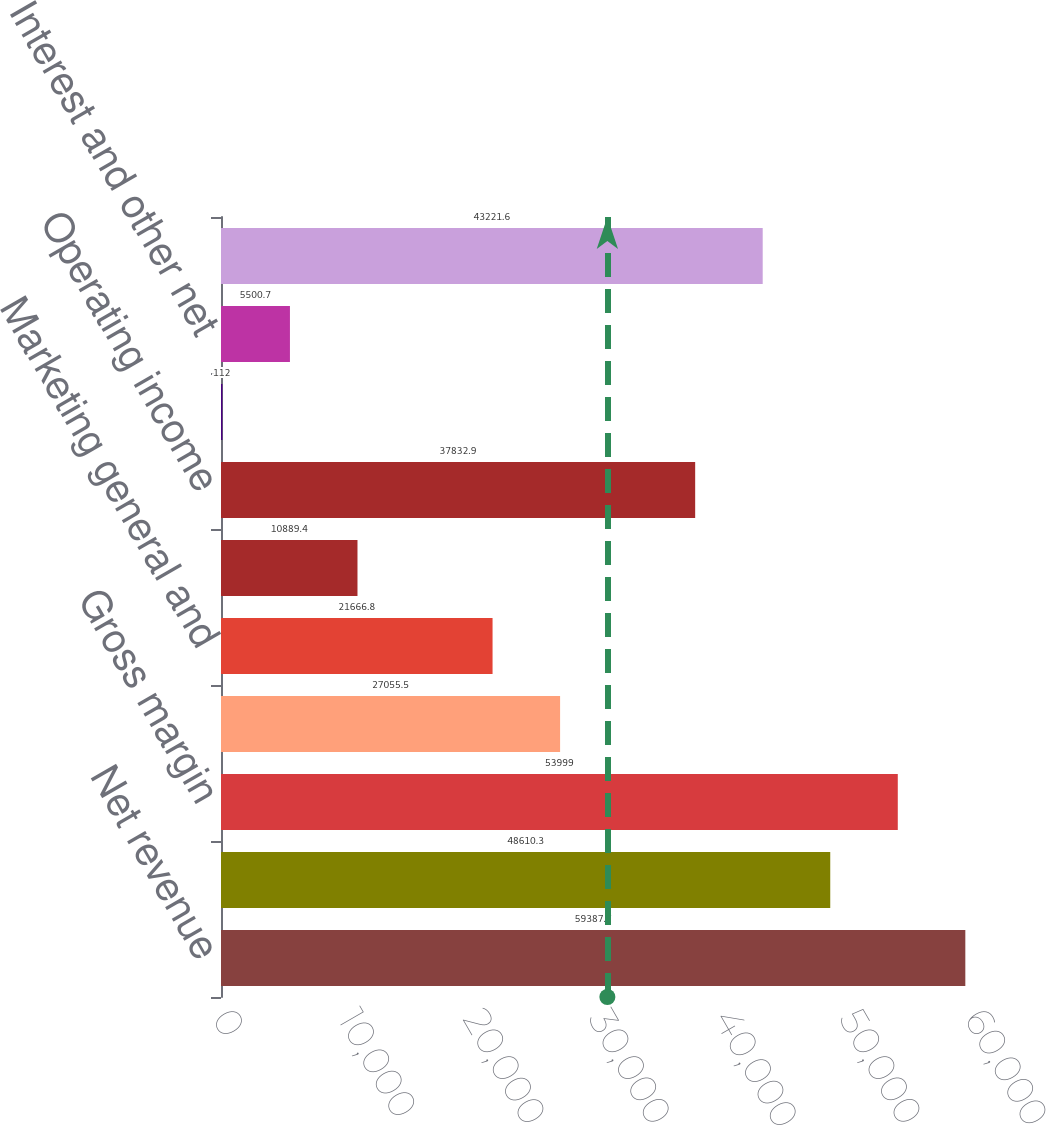Convert chart to OTSL. <chart><loc_0><loc_0><loc_500><loc_500><bar_chart><fcel>Net revenue<fcel>Cost of sales<fcel>Gross margin<fcel>Research and development<fcel>Marketing general and<fcel>Amortization of<fcel>Operating income<fcel>Gains (losses) on equity<fcel>Interest and other net<fcel>Income before taxes<nl><fcel>59387.7<fcel>48610.3<fcel>53999<fcel>27055.5<fcel>21666.8<fcel>10889.4<fcel>37832.9<fcel>112<fcel>5500.7<fcel>43221.6<nl></chart> 